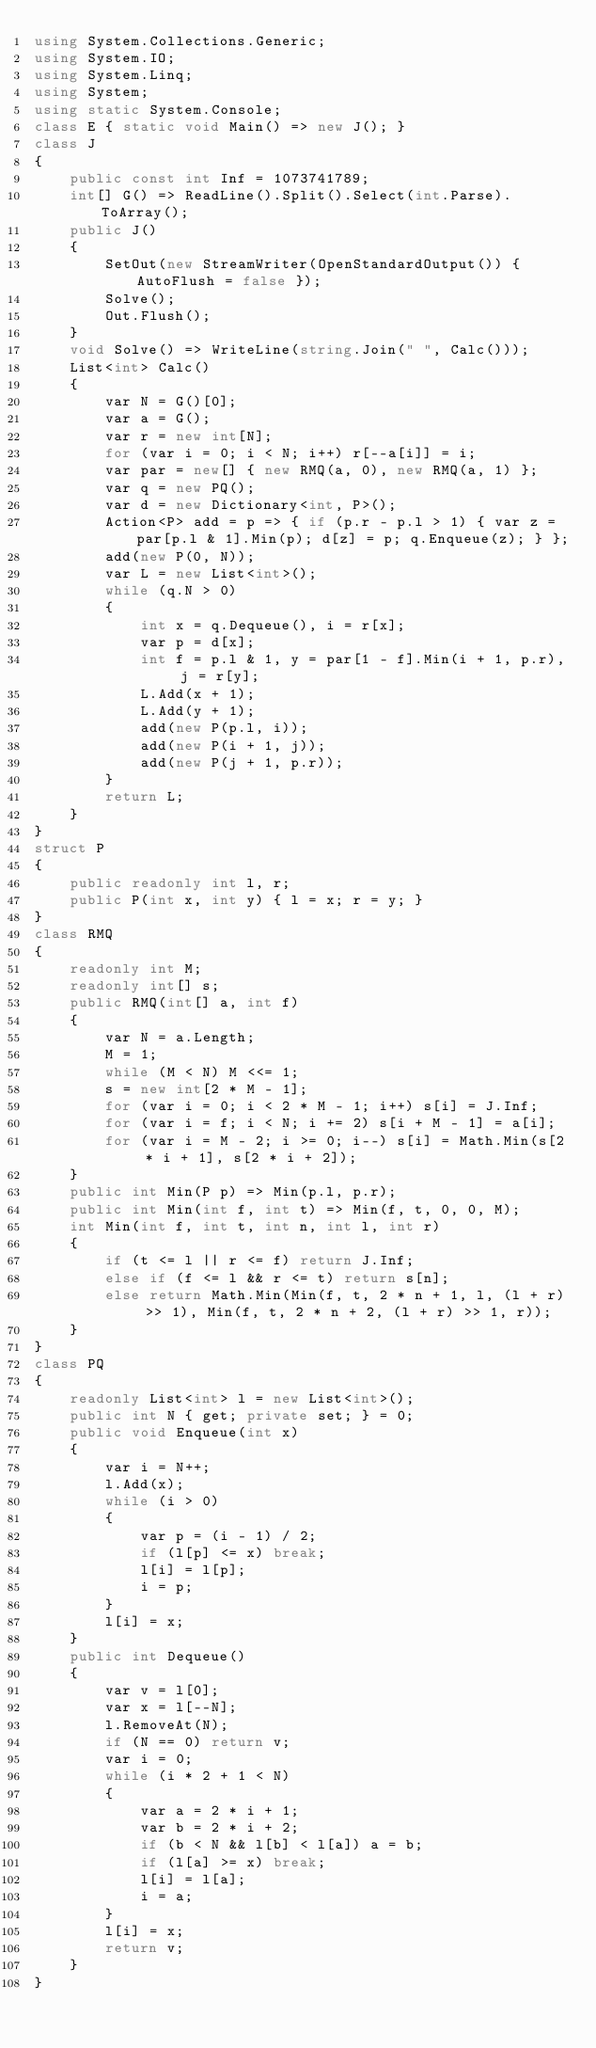Convert code to text. <code><loc_0><loc_0><loc_500><loc_500><_C#_>using System.Collections.Generic;
using System.IO;
using System.Linq;
using System;
using static System.Console;
class E { static void Main() => new J(); }
class J
{
	public const int Inf = 1073741789;
	int[] G() => ReadLine().Split().Select(int.Parse).ToArray();
	public J()
	{
		SetOut(new StreamWriter(OpenStandardOutput()) { AutoFlush = false });
		Solve();
		Out.Flush();
	}
	void Solve() => WriteLine(string.Join(" ", Calc()));
	List<int> Calc()
	{
		var N = G()[0];
		var a = G();
		var r = new int[N];
		for (var i = 0; i < N; i++) r[--a[i]] = i;
		var par = new[] { new RMQ(a, 0), new RMQ(a, 1) };
		var q = new PQ();
		var d = new Dictionary<int, P>();
		Action<P> add = p => { if (p.r - p.l > 1) { var z = par[p.l & 1].Min(p); d[z] = p; q.Enqueue(z); } };
		add(new P(0, N));
		var L = new List<int>();
		while (q.N > 0)
		{
			int x = q.Dequeue(), i = r[x];
			var p = d[x];
			int f = p.l & 1, y = par[1 - f].Min(i + 1, p.r), j = r[y];
			L.Add(x + 1);
			L.Add(y + 1);
			add(new P(p.l, i));
			add(new P(i + 1, j));
			add(new P(j + 1, p.r));
		}
		return L;
	}
}
struct P
{
	public readonly int l, r;
	public P(int x, int y) { l = x; r = y; }
}
class RMQ
{
	readonly int M;
	readonly int[] s;
	public RMQ(int[] a, int f)
	{
		var N = a.Length;
		M = 1;
		while (M < N) M <<= 1;
		s = new int[2 * M - 1];
		for (var i = 0; i < 2 * M - 1; i++) s[i] = J.Inf;
		for (var i = f; i < N; i += 2) s[i + M - 1] = a[i];
		for (var i = M - 2; i >= 0; i--) s[i] = Math.Min(s[2 * i + 1], s[2 * i + 2]);
	}
	public int Min(P p) => Min(p.l, p.r);
	public int Min(int f, int t) => Min(f, t, 0, 0, M);
	int Min(int f, int t, int n, int l, int r)
	{
		if (t <= l || r <= f) return J.Inf;
		else if (f <= l && r <= t) return s[n];
		else return Math.Min(Min(f, t, 2 * n + 1, l, (l + r) >> 1), Min(f, t, 2 * n + 2, (l + r) >> 1, r));
	}
}
class PQ
{
	readonly List<int> l = new List<int>();
	public int N { get; private set; } = 0;
	public void Enqueue(int x)
	{
		var i = N++;
		l.Add(x);
		while (i > 0)
		{
			var p = (i - 1) / 2;
			if (l[p] <= x) break;
			l[i] = l[p];
			i = p;
		}
		l[i] = x;
	}
	public int Dequeue()
	{
		var v = l[0];
		var x = l[--N];
		l.RemoveAt(N);
		if (N == 0) return v;
		var i = 0;
		while (i * 2 + 1 < N)
		{
			var a = 2 * i + 1;
			var b = 2 * i + 2;
			if (b < N && l[b] < l[a]) a = b;
			if (l[a] >= x) break;
			l[i] = l[a];
			i = a;
		}
		l[i] = x;
		return v;
	}
}</code> 